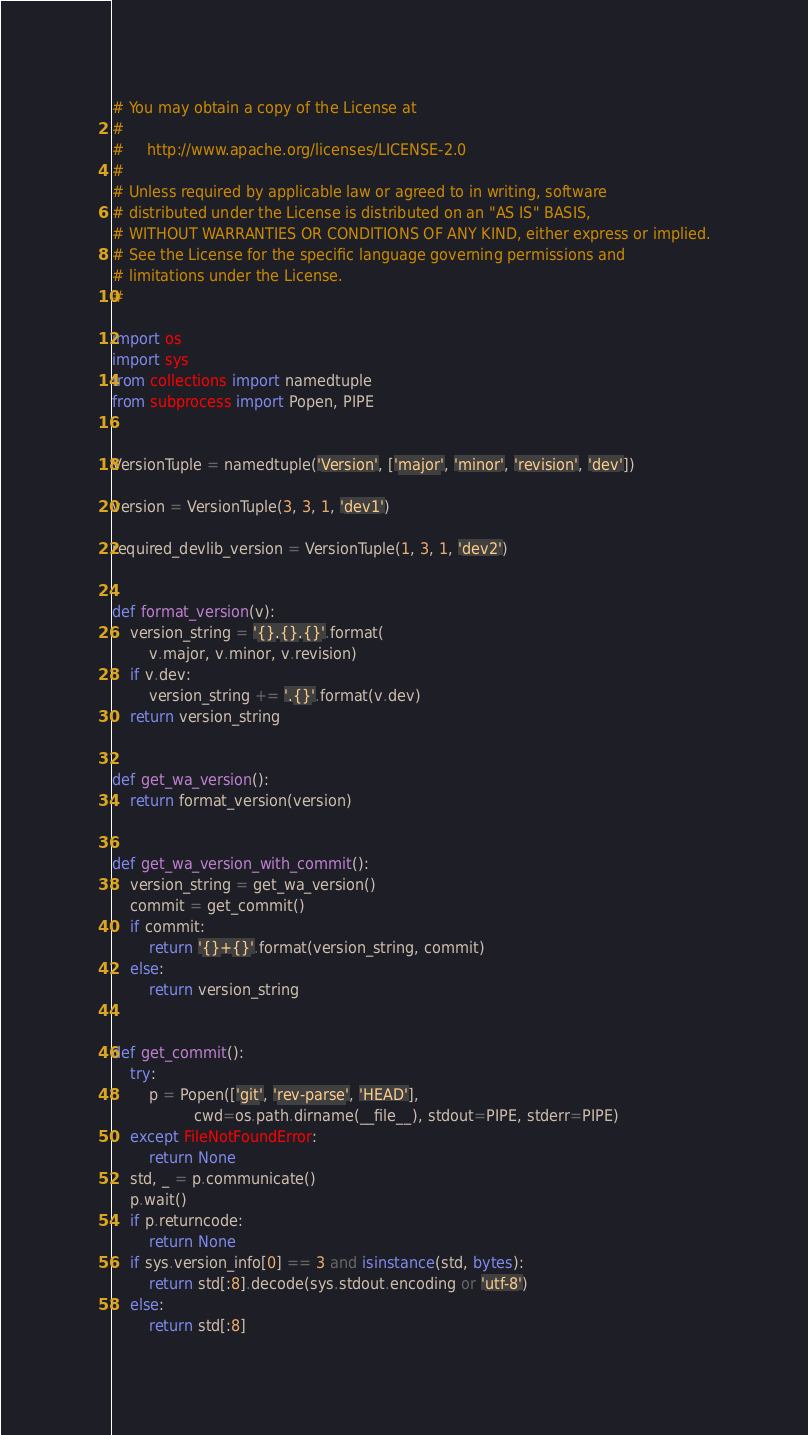<code> <loc_0><loc_0><loc_500><loc_500><_Python_># You may obtain a copy of the License at
#
#     http://www.apache.org/licenses/LICENSE-2.0
#
# Unless required by applicable law or agreed to in writing, software
# distributed under the License is distributed on an "AS IS" BASIS,
# WITHOUT WARRANTIES OR CONDITIONS OF ANY KIND, either express or implied.
# See the License for the specific language governing permissions and
# limitations under the License.
#

import os
import sys
from collections import namedtuple
from subprocess import Popen, PIPE


VersionTuple = namedtuple('Version', ['major', 'minor', 'revision', 'dev'])

version = VersionTuple(3, 3, 1, 'dev1')

required_devlib_version = VersionTuple(1, 3, 1, 'dev2')


def format_version(v):
    version_string = '{}.{}.{}'.format(
        v.major, v.minor, v.revision)
    if v.dev:
        version_string += '.{}'.format(v.dev)
    return version_string


def get_wa_version():
    return format_version(version)


def get_wa_version_with_commit():
    version_string = get_wa_version()
    commit = get_commit()
    if commit:
        return '{}+{}'.format(version_string, commit)
    else:
        return version_string


def get_commit():
    try:
        p = Popen(['git', 'rev-parse', 'HEAD'],
                  cwd=os.path.dirname(__file__), stdout=PIPE, stderr=PIPE)
    except FileNotFoundError:
        return None
    std, _ = p.communicate()
    p.wait()
    if p.returncode:
        return None
    if sys.version_info[0] == 3 and isinstance(std, bytes):
        return std[:8].decode(sys.stdout.encoding or 'utf-8')
    else:
        return std[:8]
</code> 